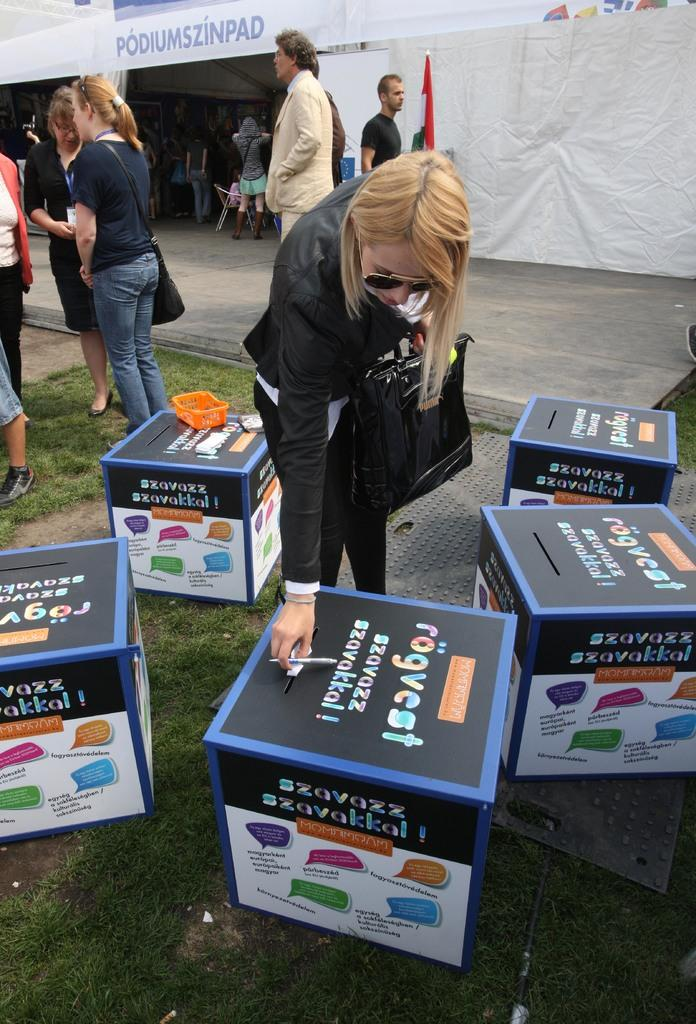What is the hair color of the woman in the image? The woman in the image has blond hair. What is the woman wearing? The woman is wearing a black dress. What is the woman doing with the paper? The woman is holding a paper and placing it in a box. Can you describe the people in the background of the image? The people in the background are standing in front of a tent. What type of cat can be seen playing with the paper in the image? There is no cat present in the image. 